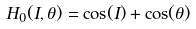<formula> <loc_0><loc_0><loc_500><loc_500>H _ { 0 } ( I , \theta ) = \cos ( I ) + \cos ( \theta )</formula> 